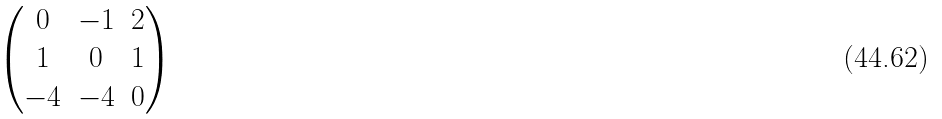<formula> <loc_0><loc_0><loc_500><loc_500>\begin{pmatrix} 0 & - 1 & 2 \\ 1 & 0 & 1 \\ - 4 & - 4 & 0 \end{pmatrix}</formula> 